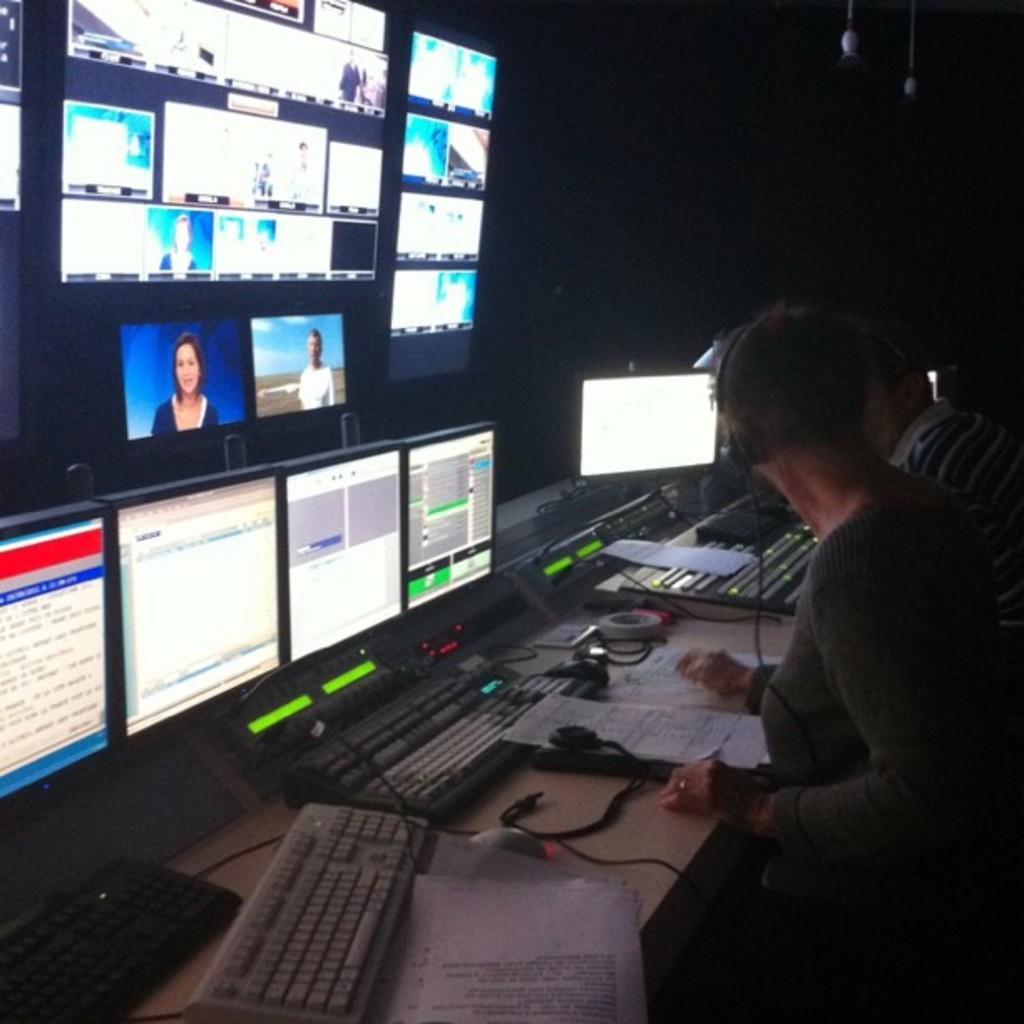How many people are in the image? There are two persons in the image. What are the persons wearing on their heads? The persons are wearing headsets. Where are the persons located in relation to the table? The persons are in front of a table. What items can be found on the table? The table contains keyboards and monitors. What is visible in the top left of the image? There are screens in the top left of the image. What type of ship can be seen sailing in the background of the image? There is no ship visible in the image; it features two persons wearing headsets in front of a table with keyboards and monitors, along with screens in the top left. 